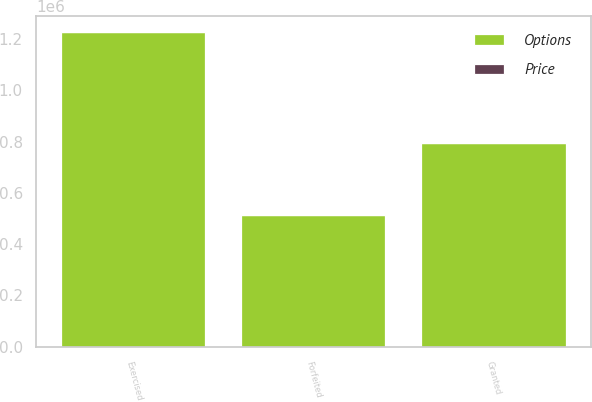Convert chart. <chart><loc_0><loc_0><loc_500><loc_500><stacked_bar_chart><ecel><fcel>Granted<fcel>Exercised<fcel>Forfeited<nl><fcel>Options<fcel>795000<fcel>1.22935e+06<fcel>513954<nl><fcel>Price<fcel>47.22<fcel>28.89<fcel>33.6<nl></chart> 